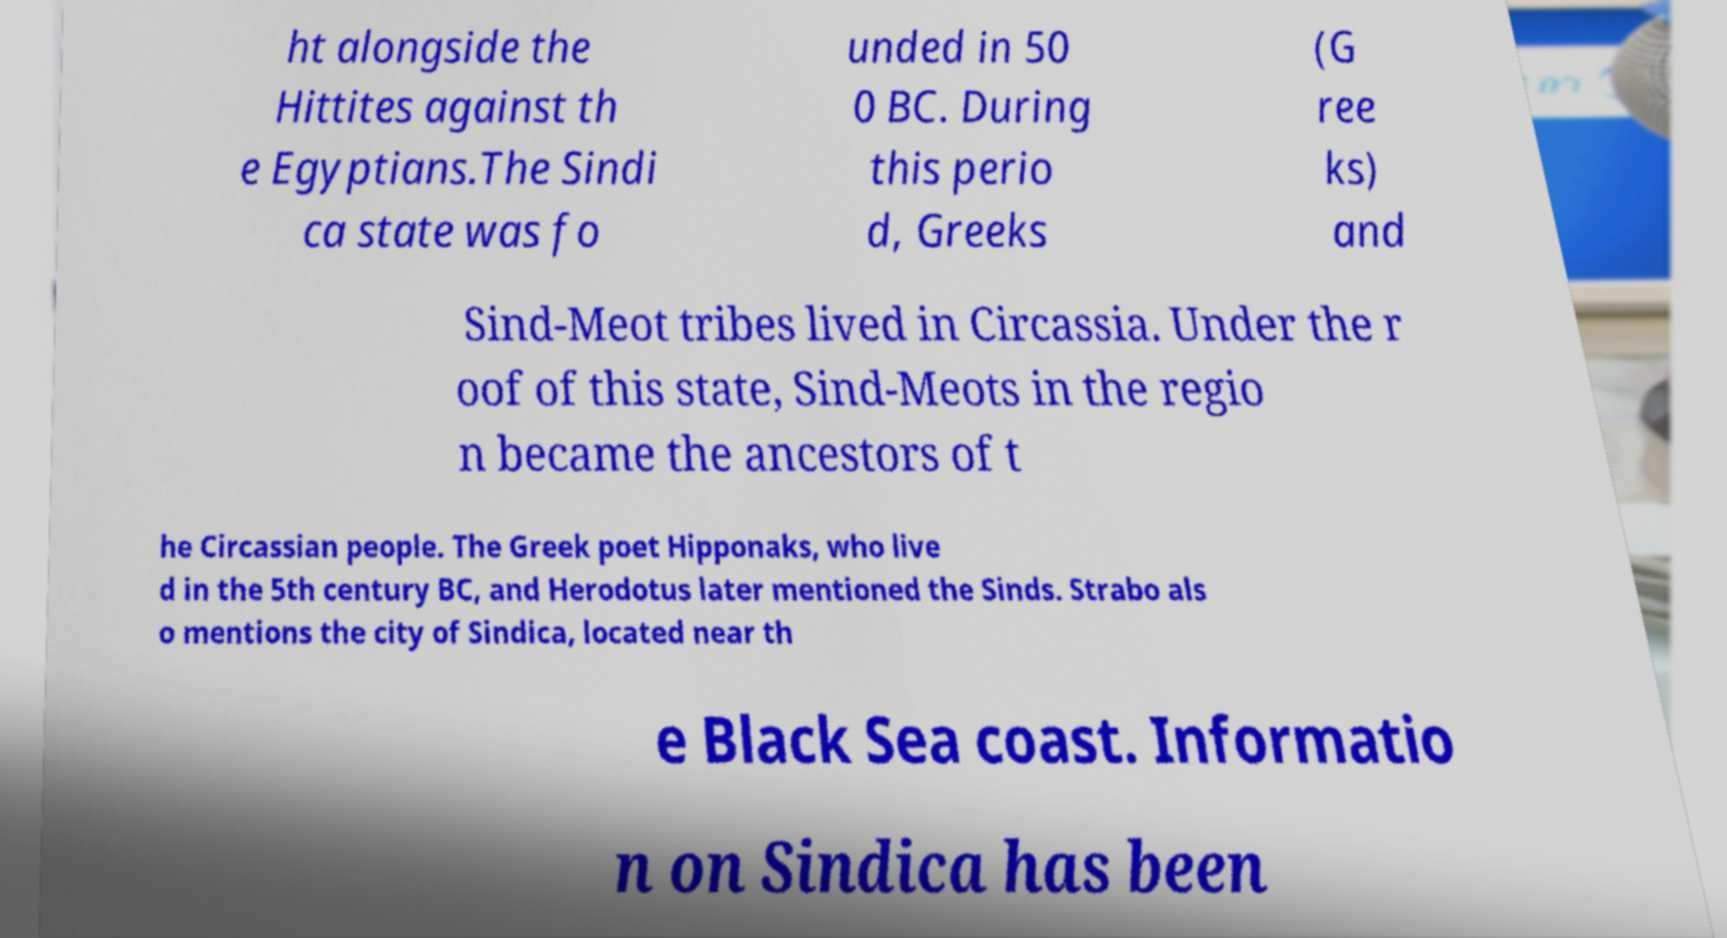What messages or text are displayed in this image? I need them in a readable, typed format. ht alongside the Hittites against th e Egyptians.The Sindi ca state was fo unded in 50 0 BC. During this perio d, Greeks (G ree ks) and Sind-Meot tribes lived in Circassia. Under the r oof of this state, Sind-Meots in the regio n became the ancestors of t he Circassian people. The Greek poet Hipponaks, who live d in the 5th century BC, and Herodotus later mentioned the Sinds. Strabo als o mentions the city of Sindica, located near th e Black Sea coast. Informatio n on Sindica has been 